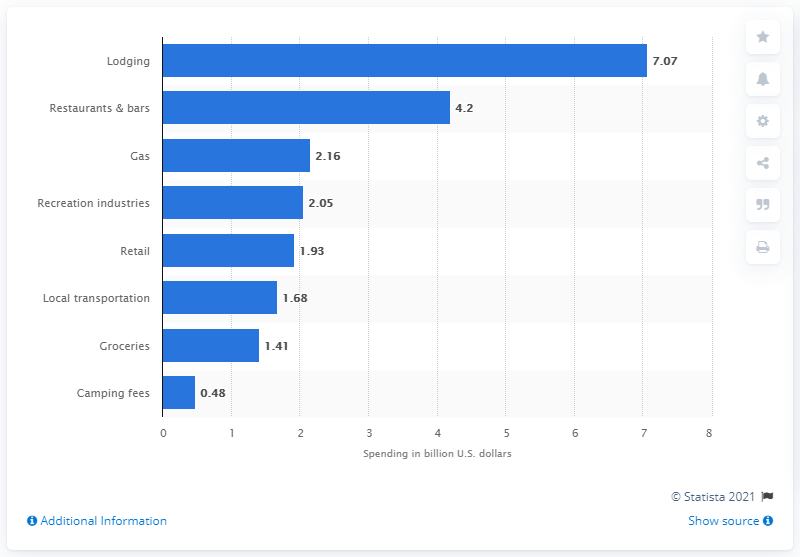Give some essential details in this illustration. In 2019, visitors to national parks spent an estimated 4.2 billion dollars on dining at restaurants and bars. 